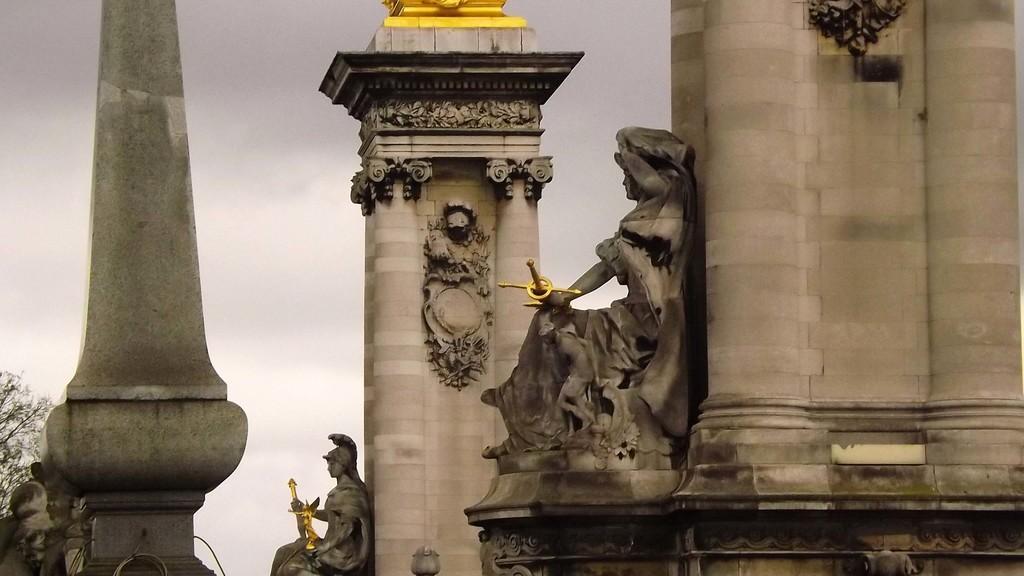Describe this image in one or two sentences. In this picture we can see few sculptures and pillars. There is a tree on the left side. 